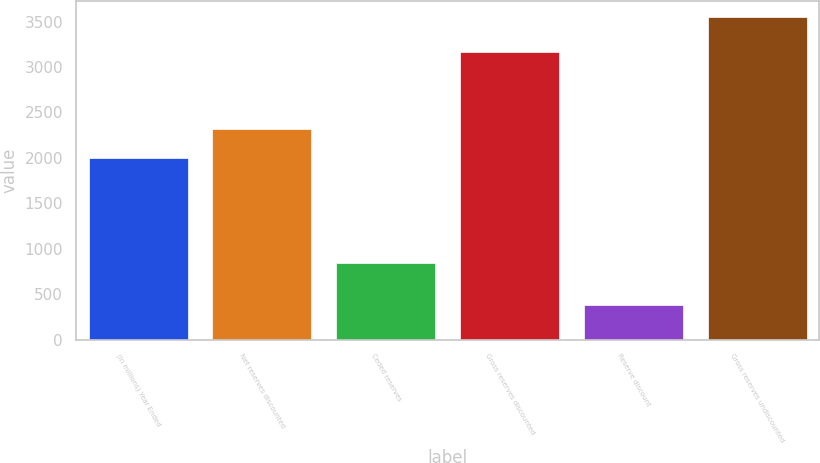Convert chart. <chart><loc_0><loc_0><loc_500><loc_500><bar_chart><fcel>(In millions) Year Ended<fcel>Net reserves discounted<fcel>Ceded reserves<fcel>Gross reserves discounted<fcel>Reserve discount<fcel>Gross reserves undiscounted<nl><fcel>2002<fcel>2323<fcel>845<fcel>3168<fcel>384<fcel>3552<nl></chart> 